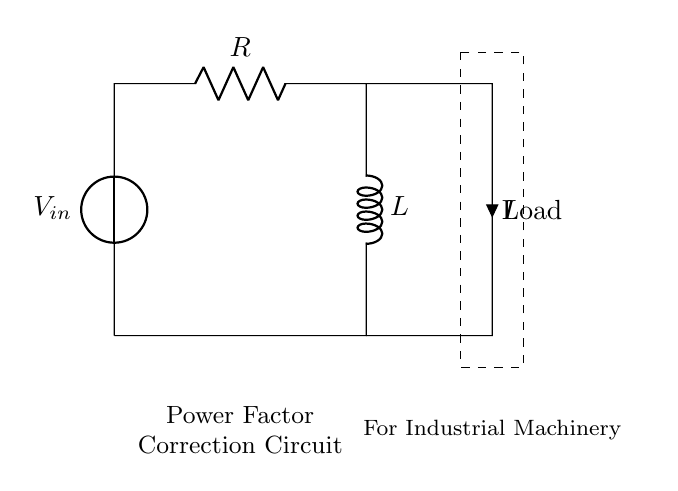What components are in this circuit? The circuit consists of a resistor and an inductor. Both elements are clearly identified in the diagram. The resistor is labeled "R" and the inductor is labeled "L".
Answer: Resistor and Inductor What is the input voltage of the circuit? The input voltage is specified at the vsource symbol labeled "V_in".
Answer: V_in What type of load is connected in this circuit? The load is indicated as "Load" in the diagram. This is a general label as the specific type of load isn't defined in the provided information.
Answer: Load What is the direction of current flow in this circuit? The current "I" is marked with an arrow pointing downwards, indicating that current flows from the top of the circuit (after the resistor and inductor) down towards the load and back to the voltage source.
Answer: Downward How does the resistor affect the power factor in the circuit? The resistor contributes to the real power in the circuit, which helps in improving the power factor by reducing reactive power. In an RL circuit, the resistor directly influences how much of the current contributes to real work done as opposed to reactive power.
Answer: Improves power factor What occurs when the circuit is under heavy load? Under heavy load, the current may increase, leading to a greater voltage drop across both the resistor and inductor, affecting the overall power factor and efficiency of the machinery. Increased load could also result in overheating of components.
Answer: Voltage drop increases How can power factor correction be achieved in this RL circuit? By adding capacitors in parallel with the load in the circuit, you can counteract the inductive reactance, thus correcting the power factor. This addition reduces the overall reactance of the circuit.
Answer: Adding capacitors 